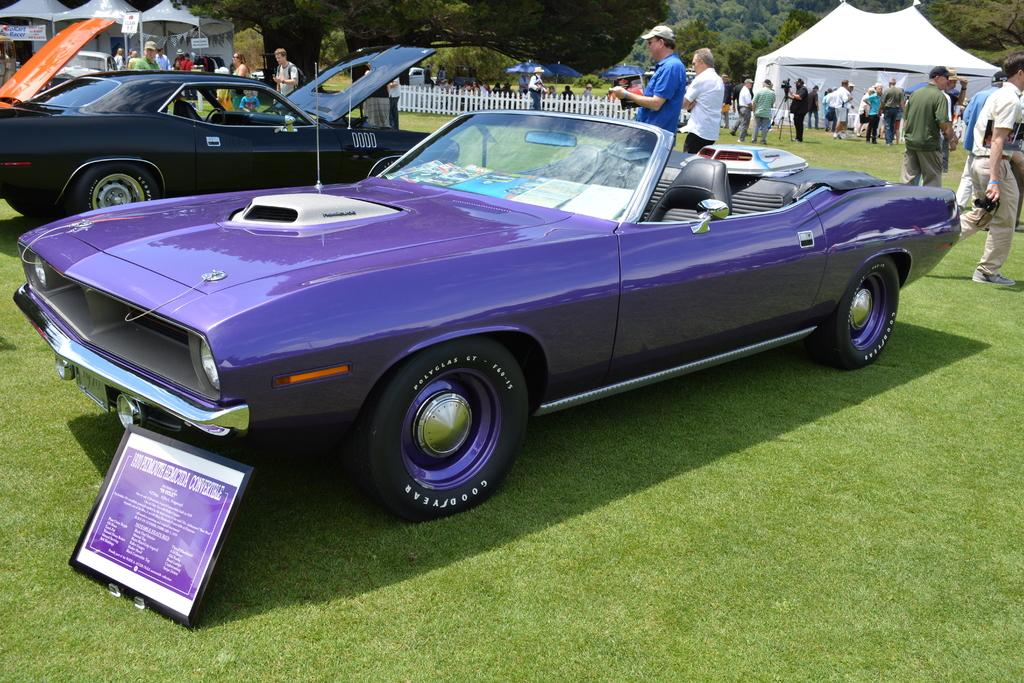What can be seen in the center of the image? There are two cars and banners in the center of the image. What is visible in the background of the image? There are trees, grass, tents, fences, and people in the background of the image. What are the people holding in the background of the image? The people are holding objects in the background of the image. Can you see the coastline in the image? There is no coastline visible in the image. What type of sweater is the person wearing in the image? There are no people wearing sweaters in the image. 